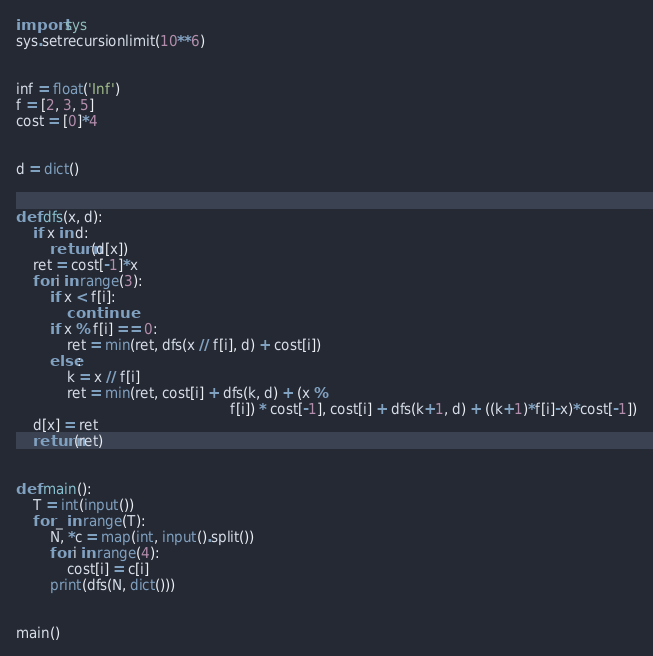Convert code to text. <code><loc_0><loc_0><loc_500><loc_500><_Python_>import sys
sys.setrecursionlimit(10**6)


inf = float('Inf')
f = [2, 3, 5]
cost = [0]*4


d = dict()


def dfs(x, d):
    if x in d:
        return(d[x])
    ret = cost[-1]*x
    for i in range(3):
        if x < f[i]:
            continue
        if x % f[i] == 0:
            ret = min(ret, dfs(x // f[i], d) + cost[i])
        else:
            k = x // f[i]
            ret = min(ret, cost[i] + dfs(k, d) + (x %
                                                  f[i]) * cost[-1], cost[i] + dfs(k+1, d) + ((k+1)*f[i]-x)*cost[-1])
    d[x] = ret
    return(ret)


def main():
    T = int(input())
    for _ in range(T):
        N, *c = map(int, input().split())
        for i in range(4):
            cost[i] = c[i]
        print(dfs(N, dict()))


main()
</code> 